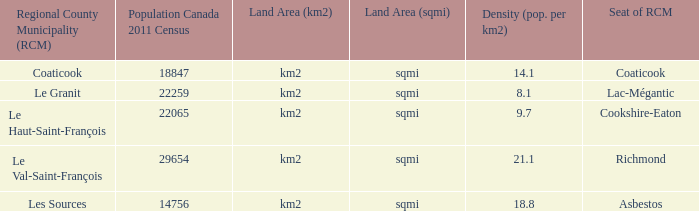What is the land coverage of the rcm that has a density of 2 Km2 (sqmi). 